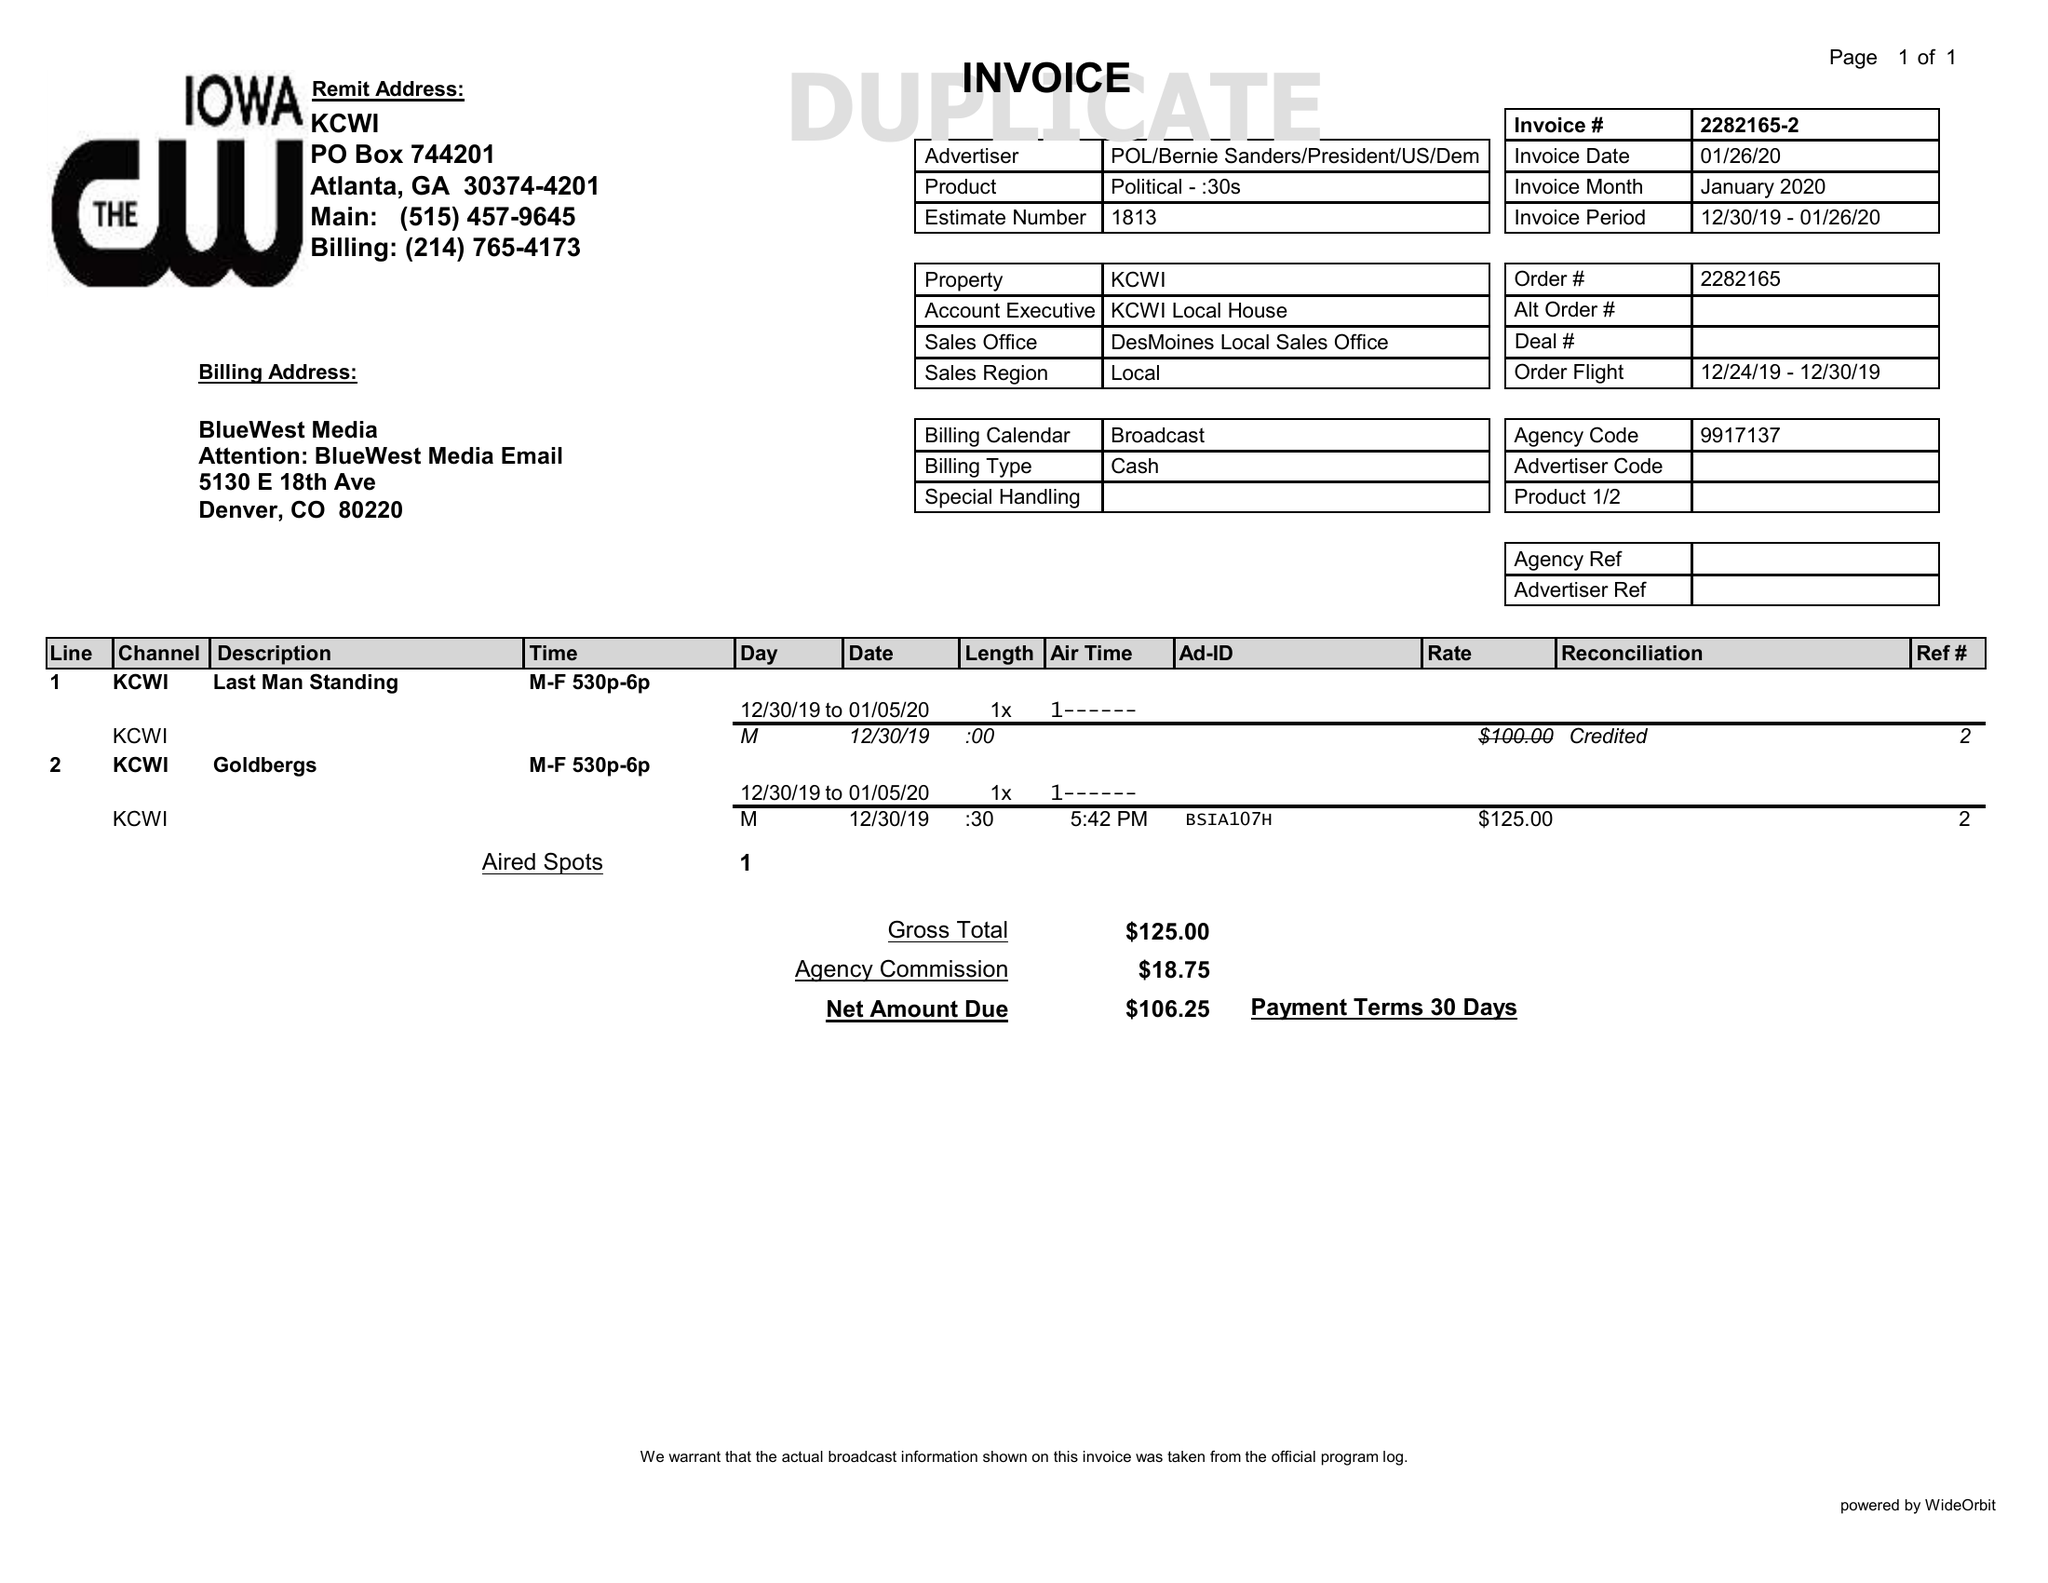What is the value for the contract_num?
Answer the question using a single word or phrase. 2282165 